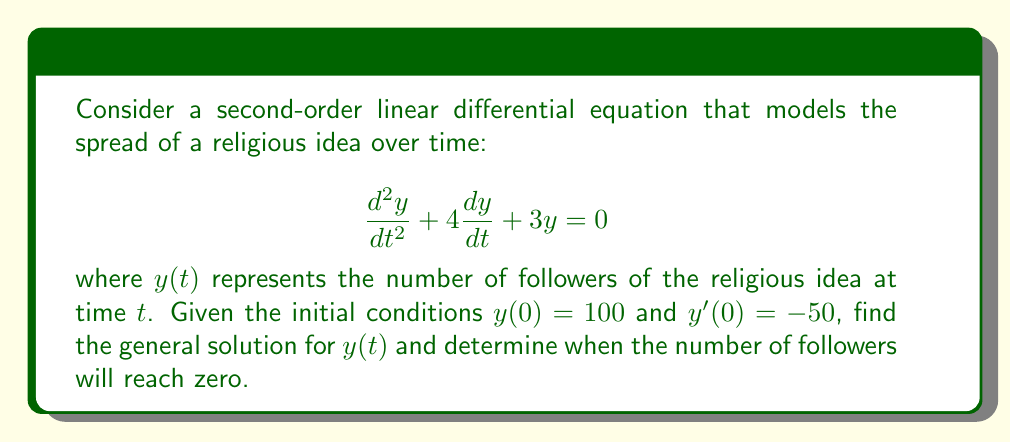Can you answer this question? To solve this second-order linear differential equation:

1) The characteristic equation is:
   $$r^2 + 4r + 3 = 0$$

2) Solving this quadratic equation:
   $$r = \frac{-4 \pm \sqrt{16 - 12}}{2} = \frac{-4 \pm \sqrt{4}}{2} = \frac{-4 \pm 2}{2}$$

3) The roots are:
   $$r_1 = -1 \text{ and } r_2 = -3$$

4) The general solution is:
   $$y(t) = C_1e^{-t} + C_2e^{-3t}$$

5) Using the initial conditions:
   $y(0) = 100$: $C_1 + C_2 = 100$
   $y'(0) = -50$: $-C_1 - 3C_2 = -50$

6) Solving this system of equations:
   $C_1 = 75$ and $C_2 = 25$

7) Therefore, the particular solution is:
   $$y(t) = 75e^{-t} + 25e^{-3t}$$

8) To find when the number of followers reaches zero, solve:
   $$75e^{-t} + 25e^{-3t} = 0$$
   $$75e^{2t} + 25 = 0$$
   $$e^{2t} = -\frac{1}{3}$$
   $$2t = \ln(\frac{1}{3})$$
   $$t = \frac{1}{2}\ln(\frac{1}{3}) \approx 0.549$$
Answer: The general solution is $y(t) = 75e^{-t} + 25e^{-3t}$. The number of followers will reach zero at approximately $t = 0.549$ time units. 